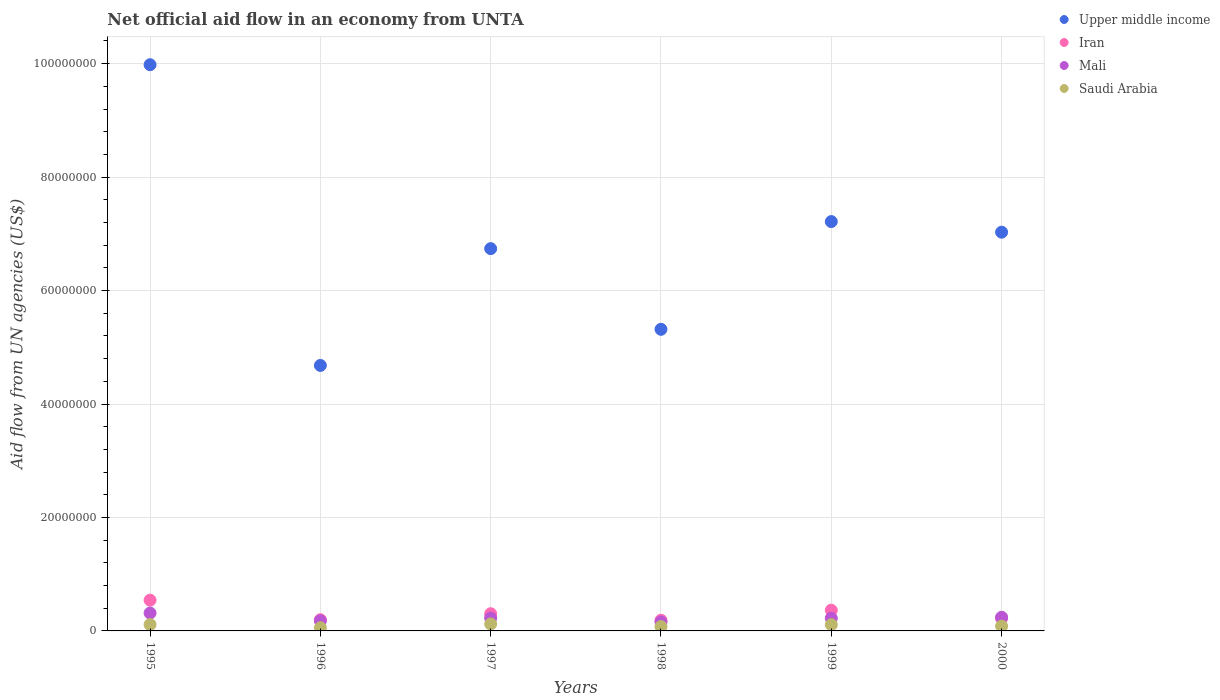Is the number of dotlines equal to the number of legend labels?
Your answer should be very brief. Yes. What is the net official aid flow in Iran in 1996?
Give a very brief answer. 1.97e+06. Across all years, what is the maximum net official aid flow in Upper middle income?
Give a very brief answer. 9.98e+07. Across all years, what is the minimum net official aid flow in Iran?
Provide a short and direct response. 1.88e+06. In which year was the net official aid flow in Mali maximum?
Offer a terse response. 1995. In which year was the net official aid flow in Mali minimum?
Provide a succinct answer. 1998. What is the total net official aid flow in Saudi Arabia in the graph?
Offer a very short reply. 5.60e+06. What is the difference between the net official aid flow in Iran in 1997 and that in 2000?
Your answer should be compact. 8.10e+05. What is the difference between the net official aid flow in Saudi Arabia in 1998 and the net official aid flow in Upper middle income in 1997?
Ensure brevity in your answer.  -6.66e+07. What is the average net official aid flow in Iran per year?
Your response must be concise. 3.03e+06. In the year 1998, what is the difference between the net official aid flow in Upper middle income and net official aid flow in Saudi Arabia?
Your response must be concise. 5.24e+07. What is the ratio of the net official aid flow in Saudi Arabia in 1995 to that in 1998?
Offer a very short reply. 1.47. Is the net official aid flow in Iran in 1995 less than that in 1998?
Ensure brevity in your answer.  No. What is the difference between the highest and the second highest net official aid flow in Mali?
Offer a very short reply. 7.40e+05. What is the difference between the highest and the lowest net official aid flow in Iran?
Offer a terse response. 3.54e+06. In how many years, is the net official aid flow in Upper middle income greater than the average net official aid flow in Upper middle income taken over all years?
Make the answer very short. 3. Does the net official aid flow in Mali monotonically increase over the years?
Offer a very short reply. No. How many dotlines are there?
Keep it short and to the point. 4. Does the graph contain grids?
Offer a very short reply. Yes. What is the title of the graph?
Offer a terse response. Net official aid flow in an economy from UNTA. Does "Ireland" appear as one of the legend labels in the graph?
Your answer should be very brief. No. What is the label or title of the X-axis?
Provide a short and direct response. Years. What is the label or title of the Y-axis?
Your response must be concise. Aid flow from UN agencies (US$). What is the Aid flow from UN agencies (US$) in Upper middle income in 1995?
Keep it short and to the point. 9.98e+07. What is the Aid flow from UN agencies (US$) in Iran in 1995?
Your answer should be compact. 5.42e+06. What is the Aid flow from UN agencies (US$) in Mali in 1995?
Provide a short and direct response. 3.15e+06. What is the Aid flow from UN agencies (US$) in Saudi Arabia in 1995?
Your answer should be very brief. 1.12e+06. What is the Aid flow from UN agencies (US$) in Upper middle income in 1996?
Ensure brevity in your answer.  4.68e+07. What is the Aid flow from UN agencies (US$) of Iran in 1996?
Provide a short and direct response. 1.97e+06. What is the Aid flow from UN agencies (US$) in Mali in 1996?
Your answer should be very brief. 1.79e+06. What is the Aid flow from UN agencies (US$) of Saudi Arabia in 1996?
Ensure brevity in your answer.  5.60e+05. What is the Aid flow from UN agencies (US$) in Upper middle income in 1997?
Your answer should be compact. 6.74e+07. What is the Aid flow from UN agencies (US$) in Iran in 1997?
Your response must be concise. 3.03e+06. What is the Aid flow from UN agencies (US$) in Mali in 1997?
Provide a short and direct response. 2.27e+06. What is the Aid flow from UN agencies (US$) of Saudi Arabia in 1997?
Your answer should be compact. 1.22e+06. What is the Aid flow from UN agencies (US$) in Upper middle income in 1998?
Provide a short and direct response. 5.32e+07. What is the Aid flow from UN agencies (US$) of Iran in 1998?
Provide a succinct answer. 1.88e+06. What is the Aid flow from UN agencies (US$) of Mali in 1998?
Ensure brevity in your answer.  1.59e+06. What is the Aid flow from UN agencies (US$) in Saudi Arabia in 1998?
Ensure brevity in your answer.  7.60e+05. What is the Aid flow from UN agencies (US$) of Upper middle income in 1999?
Provide a succinct answer. 7.22e+07. What is the Aid flow from UN agencies (US$) in Iran in 1999?
Your answer should be very brief. 3.65e+06. What is the Aid flow from UN agencies (US$) in Mali in 1999?
Ensure brevity in your answer.  2.24e+06. What is the Aid flow from UN agencies (US$) in Saudi Arabia in 1999?
Provide a succinct answer. 1.10e+06. What is the Aid flow from UN agencies (US$) in Upper middle income in 2000?
Offer a terse response. 7.03e+07. What is the Aid flow from UN agencies (US$) in Iran in 2000?
Make the answer very short. 2.22e+06. What is the Aid flow from UN agencies (US$) in Mali in 2000?
Keep it short and to the point. 2.41e+06. What is the Aid flow from UN agencies (US$) in Saudi Arabia in 2000?
Offer a very short reply. 8.40e+05. Across all years, what is the maximum Aid flow from UN agencies (US$) of Upper middle income?
Offer a terse response. 9.98e+07. Across all years, what is the maximum Aid flow from UN agencies (US$) of Iran?
Your answer should be very brief. 5.42e+06. Across all years, what is the maximum Aid flow from UN agencies (US$) of Mali?
Make the answer very short. 3.15e+06. Across all years, what is the maximum Aid flow from UN agencies (US$) in Saudi Arabia?
Give a very brief answer. 1.22e+06. Across all years, what is the minimum Aid flow from UN agencies (US$) of Upper middle income?
Keep it short and to the point. 4.68e+07. Across all years, what is the minimum Aid flow from UN agencies (US$) of Iran?
Your response must be concise. 1.88e+06. Across all years, what is the minimum Aid flow from UN agencies (US$) in Mali?
Provide a short and direct response. 1.59e+06. Across all years, what is the minimum Aid flow from UN agencies (US$) in Saudi Arabia?
Offer a terse response. 5.60e+05. What is the total Aid flow from UN agencies (US$) of Upper middle income in the graph?
Give a very brief answer. 4.10e+08. What is the total Aid flow from UN agencies (US$) of Iran in the graph?
Offer a very short reply. 1.82e+07. What is the total Aid flow from UN agencies (US$) of Mali in the graph?
Provide a short and direct response. 1.34e+07. What is the total Aid flow from UN agencies (US$) of Saudi Arabia in the graph?
Your response must be concise. 5.60e+06. What is the difference between the Aid flow from UN agencies (US$) in Upper middle income in 1995 and that in 1996?
Offer a terse response. 5.30e+07. What is the difference between the Aid flow from UN agencies (US$) of Iran in 1995 and that in 1996?
Offer a terse response. 3.45e+06. What is the difference between the Aid flow from UN agencies (US$) of Mali in 1995 and that in 1996?
Offer a terse response. 1.36e+06. What is the difference between the Aid flow from UN agencies (US$) in Saudi Arabia in 1995 and that in 1996?
Ensure brevity in your answer.  5.60e+05. What is the difference between the Aid flow from UN agencies (US$) in Upper middle income in 1995 and that in 1997?
Offer a very short reply. 3.24e+07. What is the difference between the Aid flow from UN agencies (US$) in Iran in 1995 and that in 1997?
Offer a very short reply. 2.39e+06. What is the difference between the Aid flow from UN agencies (US$) in Mali in 1995 and that in 1997?
Your answer should be compact. 8.80e+05. What is the difference between the Aid flow from UN agencies (US$) of Saudi Arabia in 1995 and that in 1997?
Provide a succinct answer. -1.00e+05. What is the difference between the Aid flow from UN agencies (US$) of Upper middle income in 1995 and that in 1998?
Your response must be concise. 4.66e+07. What is the difference between the Aid flow from UN agencies (US$) of Iran in 1995 and that in 1998?
Provide a short and direct response. 3.54e+06. What is the difference between the Aid flow from UN agencies (US$) in Mali in 1995 and that in 1998?
Offer a terse response. 1.56e+06. What is the difference between the Aid flow from UN agencies (US$) in Saudi Arabia in 1995 and that in 1998?
Ensure brevity in your answer.  3.60e+05. What is the difference between the Aid flow from UN agencies (US$) in Upper middle income in 1995 and that in 1999?
Provide a short and direct response. 2.76e+07. What is the difference between the Aid flow from UN agencies (US$) in Iran in 1995 and that in 1999?
Offer a terse response. 1.77e+06. What is the difference between the Aid flow from UN agencies (US$) in Mali in 1995 and that in 1999?
Offer a terse response. 9.10e+05. What is the difference between the Aid flow from UN agencies (US$) of Saudi Arabia in 1995 and that in 1999?
Your response must be concise. 2.00e+04. What is the difference between the Aid flow from UN agencies (US$) in Upper middle income in 1995 and that in 2000?
Provide a succinct answer. 2.95e+07. What is the difference between the Aid flow from UN agencies (US$) of Iran in 1995 and that in 2000?
Make the answer very short. 3.20e+06. What is the difference between the Aid flow from UN agencies (US$) in Mali in 1995 and that in 2000?
Your answer should be compact. 7.40e+05. What is the difference between the Aid flow from UN agencies (US$) in Upper middle income in 1996 and that in 1997?
Make the answer very short. -2.06e+07. What is the difference between the Aid flow from UN agencies (US$) in Iran in 1996 and that in 1997?
Make the answer very short. -1.06e+06. What is the difference between the Aid flow from UN agencies (US$) in Mali in 1996 and that in 1997?
Provide a short and direct response. -4.80e+05. What is the difference between the Aid flow from UN agencies (US$) in Saudi Arabia in 1996 and that in 1997?
Offer a terse response. -6.60e+05. What is the difference between the Aid flow from UN agencies (US$) of Upper middle income in 1996 and that in 1998?
Your answer should be very brief. -6.37e+06. What is the difference between the Aid flow from UN agencies (US$) of Iran in 1996 and that in 1998?
Give a very brief answer. 9.00e+04. What is the difference between the Aid flow from UN agencies (US$) of Mali in 1996 and that in 1998?
Provide a succinct answer. 2.00e+05. What is the difference between the Aid flow from UN agencies (US$) of Saudi Arabia in 1996 and that in 1998?
Your response must be concise. -2.00e+05. What is the difference between the Aid flow from UN agencies (US$) of Upper middle income in 1996 and that in 1999?
Give a very brief answer. -2.54e+07. What is the difference between the Aid flow from UN agencies (US$) of Iran in 1996 and that in 1999?
Your response must be concise. -1.68e+06. What is the difference between the Aid flow from UN agencies (US$) of Mali in 1996 and that in 1999?
Your response must be concise. -4.50e+05. What is the difference between the Aid flow from UN agencies (US$) of Saudi Arabia in 1996 and that in 1999?
Ensure brevity in your answer.  -5.40e+05. What is the difference between the Aid flow from UN agencies (US$) of Upper middle income in 1996 and that in 2000?
Your answer should be compact. -2.35e+07. What is the difference between the Aid flow from UN agencies (US$) in Mali in 1996 and that in 2000?
Make the answer very short. -6.20e+05. What is the difference between the Aid flow from UN agencies (US$) of Saudi Arabia in 1996 and that in 2000?
Make the answer very short. -2.80e+05. What is the difference between the Aid flow from UN agencies (US$) of Upper middle income in 1997 and that in 1998?
Offer a very short reply. 1.42e+07. What is the difference between the Aid flow from UN agencies (US$) in Iran in 1997 and that in 1998?
Keep it short and to the point. 1.15e+06. What is the difference between the Aid flow from UN agencies (US$) of Mali in 1997 and that in 1998?
Make the answer very short. 6.80e+05. What is the difference between the Aid flow from UN agencies (US$) of Upper middle income in 1997 and that in 1999?
Your answer should be compact. -4.77e+06. What is the difference between the Aid flow from UN agencies (US$) in Iran in 1997 and that in 1999?
Provide a succinct answer. -6.20e+05. What is the difference between the Aid flow from UN agencies (US$) of Mali in 1997 and that in 1999?
Give a very brief answer. 3.00e+04. What is the difference between the Aid flow from UN agencies (US$) in Upper middle income in 1997 and that in 2000?
Ensure brevity in your answer.  -2.90e+06. What is the difference between the Aid flow from UN agencies (US$) of Iran in 1997 and that in 2000?
Your answer should be compact. 8.10e+05. What is the difference between the Aid flow from UN agencies (US$) of Upper middle income in 1998 and that in 1999?
Keep it short and to the point. -1.90e+07. What is the difference between the Aid flow from UN agencies (US$) of Iran in 1998 and that in 1999?
Ensure brevity in your answer.  -1.77e+06. What is the difference between the Aid flow from UN agencies (US$) of Mali in 1998 and that in 1999?
Keep it short and to the point. -6.50e+05. What is the difference between the Aid flow from UN agencies (US$) of Upper middle income in 1998 and that in 2000?
Offer a terse response. -1.71e+07. What is the difference between the Aid flow from UN agencies (US$) in Mali in 1998 and that in 2000?
Make the answer very short. -8.20e+05. What is the difference between the Aid flow from UN agencies (US$) of Saudi Arabia in 1998 and that in 2000?
Provide a short and direct response. -8.00e+04. What is the difference between the Aid flow from UN agencies (US$) of Upper middle income in 1999 and that in 2000?
Provide a short and direct response. 1.87e+06. What is the difference between the Aid flow from UN agencies (US$) of Iran in 1999 and that in 2000?
Your response must be concise. 1.43e+06. What is the difference between the Aid flow from UN agencies (US$) in Upper middle income in 1995 and the Aid flow from UN agencies (US$) in Iran in 1996?
Provide a succinct answer. 9.78e+07. What is the difference between the Aid flow from UN agencies (US$) of Upper middle income in 1995 and the Aid flow from UN agencies (US$) of Mali in 1996?
Keep it short and to the point. 9.80e+07. What is the difference between the Aid flow from UN agencies (US$) of Upper middle income in 1995 and the Aid flow from UN agencies (US$) of Saudi Arabia in 1996?
Keep it short and to the point. 9.92e+07. What is the difference between the Aid flow from UN agencies (US$) of Iran in 1995 and the Aid flow from UN agencies (US$) of Mali in 1996?
Make the answer very short. 3.63e+06. What is the difference between the Aid flow from UN agencies (US$) of Iran in 1995 and the Aid flow from UN agencies (US$) of Saudi Arabia in 1996?
Keep it short and to the point. 4.86e+06. What is the difference between the Aid flow from UN agencies (US$) of Mali in 1995 and the Aid flow from UN agencies (US$) of Saudi Arabia in 1996?
Give a very brief answer. 2.59e+06. What is the difference between the Aid flow from UN agencies (US$) in Upper middle income in 1995 and the Aid flow from UN agencies (US$) in Iran in 1997?
Your answer should be very brief. 9.68e+07. What is the difference between the Aid flow from UN agencies (US$) in Upper middle income in 1995 and the Aid flow from UN agencies (US$) in Mali in 1997?
Keep it short and to the point. 9.75e+07. What is the difference between the Aid flow from UN agencies (US$) of Upper middle income in 1995 and the Aid flow from UN agencies (US$) of Saudi Arabia in 1997?
Make the answer very short. 9.86e+07. What is the difference between the Aid flow from UN agencies (US$) of Iran in 1995 and the Aid flow from UN agencies (US$) of Mali in 1997?
Make the answer very short. 3.15e+06. What is the difference between the Aid flow from UN agencies (US$) of Iran in 1995 and the Aid flow from UN agencies (US$) of Saudi Arabia in 1997?
Your answer should be very brief. 4.20e+06. What is the difference between the Aid flow from UN agencies (US$) in Mali in 1995 and the Aid flow from UN agencies (US$) in Saudi Arabia in 1997?
Make the answer very short. 1.93e+06. What is the difference between the Aid flow from UN agencies (US$) in Upper middle income in 1995 and the Aid flow from UN agencies (US$) in Iran in 1998?
Provide a short and direct response. 9.79e+07. What is the difference between the Aid flow from UN agencies (US$) of Upper middle income in 1995 and the Aid flow from UN agencies (US$) of Mali in 1998?
Keep it short and to the point. 9.82e+07. What is the difference between the Aid flow from UN agencies (US$) of Upper middle income in 1995 and the Aid flow from UN agencies (US$) of Saudi Arabia in 1998?
Make the answer very short. 9.90e+07. What is the difference between the Aid flow from UN agencies (US$) in Iran in 1995 and the Aid flow from UN agencies (US$) in Mali in 1998?
Make the answer very short. 3.83e+06. What is the difference between the Aid flow from UN agencies (US$) of Iran in 1995 and the Aid flow from UN agencies (US$) of Saudi Arabia in 1998?
Your answer should be compact. 4.66e+06. What is the difference between the Aid flow from UN agencies (US$) of Mali in 1995 and the Aid flow from UN agencies (US$) of Saudi Arabia in 1998?
Ensure brevity in your answer.  2.39e+06. What is the difference between the Aid flow from UN agencies (US$) of Upper middle income in 1995 and the Aid flow from UN agencies (US$) of Iran in 1999?
Give a very brief answer. 9.62e+07. What is the difference between the Aid flow from UN agencies (US$) in Upper middle income in 1995 and the Aid flow from UN agencies (US$) in Mali in 1999?
Your response must be concise. 9.76e+07. What is the difference between the Aid flow from UN agencies (US$) in Upper middle income in 1995 and the Aid flow from UN agencies (US$) in Saudi Arabia in 1999?
Give a very brief answer. 9.87e+07. What is the difference between the Aid flow from UN agencies (US$) in Iran in 1995 and the Aid flow from UN agencies (US$) in Mali in 1999?
Make the answer very short. 3.18e+06. What is the difference between the Aid flow from UN agencies (US$) of Iran in 1995 and the Aid flow from UN agencies (US$) of Saudi Arabia in 1999?
Provide a short and direct response. 4.32e+06. What is the difference between the Aid flow from UN agencies (US$) in Mali in 1995 and the Aid flow from UN agencies (US$) in Saudi Arabia in 1999?
Provide a short and direct response. 2.05e+06. What is the difference between the Aid flow from UN agencies (US$) in Upper middle income in 1995 and the Aid flow from UN agencies (US$) in Iran in 2000?
Give a very brief answer. 9.76e+07. What is the difference between the Aid flow from UN agencies (US$) in Upper middle income in 1995 and the Aid flow from UN agencies (US$) in Mali in 2000?
Keep it short and to the point. 9.74e+07. What is the difference between the Aid flow from UN agencies (US$) in Upper middle income in 1995 and the Aid flow from UN agencies (US$) in Saudi Arabia in 2000?
Provide a short and direct response. 9.90e+07. What is the difference between the Aid flow from UN agencies (US$) of Iran in 1995 and the Aid flow from UN agencies (US$) of Mali in 2000?
Keep it short and to the point. 3.01e+06. What is the difference between the Aid flow from UN agencies (US$) of Iran in 1995 and the Aid flow from UN agencies (US$) of Saudi Arabia in 2000?
Your response must be concise. 4.58e+06. What is the difference between the Aid flow from UN agencies (US$) in Mali in 1995 and the Aid flow from UN agencies (US$) in Saudi Arabia in 2000?
Make the answer very short. 2.31e+06. What is the difference between the Aid flow from UN agencies (US$) in Upper middle income in 1996 and the Aid flow from UN agencies (US$) in Iran in 1997?
Ensure brevity in your answer.  4.38e+07. What is the difference between the Aid flow from UN agencies (US$) in Upper middle income in 1996 and the Aid flow from UN agencies (US$) in Mali in 1997?
Your response must be concise. 4.45e+07. What is the difference between the Aid flow from UN agencies (US$) in Upper middle income in 1996 and the Aid flow from UN agencies (US$) in Saudi Arabia in 1997?
Offer a terse response. 4.56e+07. What is the difference between the Aid flow from UN agencies (US$) in Iran in 1996 and the Aid flow from UN agencies (US$) in Mali in 1997?
Give a very brief answer. -3.00e+05. What is the difference between the Aid flow from UN agencies (US$) in Iran in 1996 and the Aid flow from UN agencies (US$) in Saudi Arabia in 1997?
Provide a short and direct response. 7.50e+05. What is the difference between the Aid flow from UN agencies (US$) of Mali in 1996 and the Aid flow from UN agencies (US$) of Saudi Arabia in 1997?
Offer a very short reply. 5.70e+05. What is the difference between the Aid flow from UN agencies (US$) in Upper middle income in 1996 and the Aid flow from UN agencies (US$) in Iran in 1998?
Your answer should be very brief. 4.49e+07. What is the difference between the Aid flow from UN agencies (US$) in Upper middle income in 1996 and the Aid flow from UN agencies (US$) in Mali in 1998?
Make the answer very short. 4.52e+07. What is the difference between the Aid flow from UN agencies (US$) of Upper middle income in 1996 and the Aid flow from UN agencies (US$) of Saudi Arabia in 1998?
Ensure brevity in your answer.  4.60e+07. What is the difference between the Aid flow from UN agencies (US$) of Iran in 1996 and the Aid flow from UN agencies (US$) of Saudi Arabia in 1998?
Your response must be concise. 1.21e+06. What is the difference between the Aid flow from UN agencies (US$) in Mali in 1996 and the Aid flow from UN agencies (US$) in Saudi Arabia in 1998?
Provide a succinct answer. 1.03e+06. What is the difference between the Aid flow from UN agencies (US$) in Upper middle income in 1996 and the Aid flow from UN agencies (US$) in Iran in 1999?
Make the answer very short. 4.32e+07. What is the difference between the Aid flow from UN agencies (US$) of Upper middle income in 1996 and the Aid flow from UN agencies (US$) of Mali in 1999?
Offer a very short reply. 4.46e+07. What is the difference between the Aid flow from UN agencies (US$) in Upper middle income in 1996 and the Aid flow from UN agencies (US$) in Saudi Arabia in 1999?
Your response must be concise. 4.57e+07. What is the difference between the Aid flow from UN agencies (US$) in Iran in 1996 and the Aid flow from UN agencies (US$) in Saudi Arabia in 1999?
Provide a short and direct response. 8.70e+05. What is the difference between the Aid flow from UN agencies (US$) of Mali in 1996 and the Aid flow from UN agencies (US$) of Saudi Arabia in 1999?
Offer a very short reply. 6.90e+05. What is the difference between the Aid flow from UN agencies (US$) in Upper middle income in 1996 and the Aid flow from UN agencies (US$) in Iran in 2000?
Your response must be concise. 4.46e+07. What is the difference between the Aid flow from UN agencies (US$) of Upper middle income in 1996 and the Aid flow from UN agencies (US$) of Mali in 2000?
Make the answer very short. 4.44e+07. What is the difference between the Aid flow from UN agencies (US$) of Upper middle income in 1996 and the Aid flow from UN agencies (US$) of Saudi Arabia in 2000?
Ensure brevity in your answer.  4.60e+07. What is the difference between the Aid flow from UN agencies (US$) in Iran in 1996 and the Aid flow from UN agencies (US$) in Mali in 2000?
Make the answer very short. -4.40e+05. What is the difference between the Aid flow from UN agencies (US$) in Iran in 1996 and the Aid flow from UN agencies (US$) in Saudi Arabia in 2000?
Provide a short and direct response. 1.13e+06. What is the difference between the Aid flow from UN agencies (US$) in Mali in 1996 and the Aid flow from UN agencies (US$) in Saudi Arabia in 2000?
Provide a succinct answer. 9.50e+05. What is the difference between the Aid flow from UN agencies (US$) in Upper middle income in 1997 and the Aid flow from UN agencies (US$) in Iran in 1998?
Make the answer very short. 6.55e+07. What is the difference between the Aid flow from UN agencies (US$) of Upper middle income in 1997 and the Aid flow from UN agencies (US$) of Mali in 1998?
Make the answer very short. 6.58e+07. What is the difference between the Aid flow from UN agencies (US$) of Upper middle income in 1997 and the Aid flow from UN agencies (US$) of Saudi Arabia in 1998?
Your answer should be compact. 6.66e+07. What is the difference between the Aid flow from UN agencies (US$) of Iran in 1997 and the Aid flow from UN agencies (US$) of Mali in 1998?
Offer a very short reply. 1.44e+06. What is the difference between the Aid flow from UN agencies (US$) in Iran in 1997 and the Aid flow from UN agencies (US$) in Saudi Arabia in 1998?
Offer a very short reply. 2.27e+06. What is the difference between the Aid flow from UN agencies (US$) of Mali in 1997 and the Aid flow from UN agencies (US$) of Saudi Arabia in 1998?
Offer a terse response. 1.51e+06. What is the difference between the Aid flow from UN agencies (US$) in Upper middle income in 1997 and the Aid flow from UN agencies (US$) in Iran in 1999?
Make the answer very short. 6.37e+07. What is the difference between the Aid flow from UN agencies (US$) in Upper middle income in 1997 and the Aid flow from UN agencies (US$) in Mali in 1999?
Keep it short and to the point. 6.52e+07. What is the difference between the Aid flow from UN agencies (US$) in Upper middle income in 1997 and the Aid flow from UN agencies (US$) in Saudi Arabia in 1999?
Make the answer very short. 6.63e+07. What is the difference between the Aid flow from UN agencies (US$) in Iran in 1997 and the Aid flow from UN agencies (US$) in Mali in 1999?
Your response must be concise. 7.90e+05. What is the difference between the Aid flow from UN agencies (US$) of Iran in 1997 and the Aid flow from UN agencies (US$) of Saudi Arabia in 1999?
Provide a short and direct response. 1.93e+06. What is the difference between the Aid flow from UN agencies (US$) of Mali in 1997 and the Aid flow from UN agencies (US$) of Saudi Arabia in 1999?
Give a very brief answer. 1.17e+06. What is the difference between the Aid flow from UN agencies (US$) in Upper middle income in 1997 and the Aid flow from UN agencies (US$) in Iran in 2000?
Offer a very short reply. 6.52e+07. What is the difference between the Aid flow from UN agencies (US$) in Upper middle income in 1997 and the Aid flow from UN agencies (US$) in Mali in 2000?
Offer a very short reply. 6.50e+07. What is the difference between the Aid flow from UN agencies (US$) in Upper middle income in 1997 and the Aid flow from UN agencies (US$) in Saudi Arabia in 2000?
Your response must be concise. 6.66e+07. What is the difference between the Aid flow from UN agencies (US$) of Iran in 1997 and the Aid flow from UN agencies (US$) of Mali in 2000?
Offer a very short reply. 6.20e+05. What is the difference between the Aid flow from UN agencies (US$) in Iran in 1997 and the Aid flow from UN agencies (US$) in Saudi Arabia in 2000?
Provide a succinct answer. 2.19e+06. What is the difference between the Aid flow from UN agencies (US$) of Mali in 1997 and the Aid flow from UN agencies (US$) of Saudi Arabia in 2000?
Your answer should be compact. 1.43e+06. What is the difference between the Aid flow from UN agencies (US$) of Upper middle income in 1998 and the Aid flow from UN agencies (US$) of Iran in 1999?
Give a very brief answer. 4.95e+07. What is the difference between the Aid flow from UN agencies (US$) in Upper middle income in 1998 and the Aid flow from UN agencies (US$) in Mali in 1999?
Offer a terse response. 5.09e+07. What is the difference between the Aid flow from UN agencies (US$) in Upper middle income in 1998 and the Aid flow from UN agencies (US$) in Saudi Arabia in 1999?
Make the answer very short. 5.21e+07. What is the difference between the Aid flow from UN agencies (US$) of Iran in 1998 and the Aid flow from UN agencies (US$) of Mali in 1999?
Your answer should be compact. -3.60e+05. What is the difference between the Aid flow from UN agencies (US$) of Iran in 1998 and the Aid flow from UN agencies (US$) of Saudi Arabia in 1999?
Your response must be concise. 7.80e+05. What is the difference between the Aid flow from UN agencies (US$) in Upper middle income in 1998 and the Aid flow from UN agencies (US$) in Iran in 2000?
Make the answer very short. 5.10e+07. What is the difference between the Aid flow from UN agencies (US$) in Upper middle income in 1998 and the Aid flow from UN agencies (US$) in Mali in 2000?
Your answer should be very brief. 5.08e+07. What is the difference between the Aid flow from UN agencies (US$) in Upper middle income in 1998 and the Aid flow from UN agencies (US$) in Saudi Arabia in 2000?
Make the answer very short. 5.23e+07. What is the difference between the Aid flow from UN agencies (US$) in Iran in 1998 and the Aid flow from UN agencies (US$) in Mali in 2000?
Provide a succinct answer. -5.30e+05. What is the difference between the Aid flow from UN agencies (US$) of Iran in 1998 and the Aid flow from UN agencies (US$) of Saudi Arabia in 2000?
Your response must be concise. 1.04e+06. What is the difference between the Aid flow from UN agencies (US$) in Mali in 1998 and the Aid flow from UN agencies (US$) in Saudi Arabia in 2000?
Offer a very short reply. 7.50e+05. What is the difference between the Aid flow from UN agencies (US$) in Upper middle income in 1999 and the Aid flow from UN agencies (US$) in Iran in 2000?
Provide a succinct answer. 6.99e+07. What is the difference between the Aid flow from UN agencies (US$) in Upper middle income in 1999 and the Aid flow from UN agencies (US$) in Mali in 2000?
Give a very brief answer. 6.98e+07. What is the difference between the Aid flow from UN agencies (US$) in Upper middle income in 1999 and the Aid flow from UN agencies (US$) in Saudi Arabia in 2000?
Your answer should be compact. 7.13e+07. What is the difference between the Aid flow from UN agencies (US$) in Iran in 1999 and the Aid flow from UN agencies (US$) in Mali in 2000?
Give a very brief answer. 1.24e+06. What is the difference between the Aid flow from UN agencies (US$) in Iran in 1999 and the Aid flow from UN agencies (US$) in Saudi Arabia in 2000?
Your response must be concise. 2.81e+06. What is the difference between the Aid flow from UN agencies (US$) of Mali in 1999 and the Aid flow from UN agencies (US$) of Saudi Arabia in 2000?
Your answer should be very brief. 1.40e+06. What is the average Aid flow from UN agencies (US$) in Upper middle income per year?
Make the answer very short. 6.83e+07. What is the average Aid flow from UN agencies (US$) in Iran per year?
Your answer should be very brief. 3.03e+06. What is the average Aid flow from UN agencies (US$) of Mali per year?
Your response must be concise. 2.24e+06. What is the average Aid flow from UN agencies (US$) of Saudi Arabia per year?
Your answer should be very brief. 9.33e+05. In the year 1995, what is the difference between the Aid flow from UN agencies (US$) of Upper middle income and Aid flow from UN agencies (US$) of Iran?
Make the answer very short. 9.44e+07. In the year 1995, what is the difference between the Aid flow from UN agencies (US$) of Upper middle income and Aid flow from UN agencies (US$) of Mali?
Make the answer very short. 9.67e+07. In the year 1995, what is the difference between the Aid flow from UN agencies (US$) in Upper middle income and Aid flow from UN agencies (US$) in Saudi Arabia?
Make the answer very short. 9.87e+07. In the year 1995, what is the difference between the Aid flow from UN agencies (US$) of Iran and Aid flow from UN agencies (US$) of Mali?
Give a very brief answer. 2.27e+06. In the year 1995, what is the difference between the Aid flow from UN agencies (US$) in Iran and Aid flow from UN agencies (US$) in Saudi Arabia?
Your answer should be very brief. 4.30e+06. In the year 1995, what is the difference between the Aid flow from UN agencies (US$) in Mali and Aid flow from UN agencies (US$) in Saudi Arabia?
Offer a very short reply. 2.03e+06. In the year 1996, what is the difference between the Aid flow from UN agencies (US$) in Upper middle income and Aid flow from UN agencies (US$) in Iran?
Provide a short and direct response. 4.48e+07. In the year 1996, what is the difference between the Aid flow from UN agencies (US$) of Upper middle income and Aid flow from UN agencies (US$) of Mali?
Offer a very short reply. 4.50e+07. In the year 1996, what is the difference between the Aid flow from UN agencies (US$) in Upper middle income and Aid flow from UN agencies (US$) in Saudi Arabia?
Your answer should be compact. 4.62e+07. In the year 1996, what is the difference between the Aid flow from UN agencies (US$) of Iran and Aid flow from UN agencies (US$) of Mali?
Your answer should be very brief. 1.80e+05. In the year 1996, what is the difference between the Aid flow from UN agencies (US$) in Iran and Aid flow from UN agencies (US$) in Saudi Arabia?
Offer a very short reply. 1.41e+06. In the year 1996, what is the difference between the Aid flow from UN agencies (US$) in Mali and Aid flow from UN agencies (US$) in Saudi Arabia?
Offer a very short reply. 1.23e+06. In the year 1997, what is the difference between the Aid flow from UN agencies (US$) in Upper middle income and Aid flow from UN agencies (US$) in Iran?
Your response must be concise. 6.44e+07. In the year 1997, what is the difference between the Aid flow from UN agencies (US$) in Upper middle income and Aid flow from UN agencies (US$) in Mali?
Your answer should be compact. 6.51e+07. In the year 1997, what is the difference between the Aid flow from UN agencies (US$) of Upper middle income and Aid flow from UN agencies (US$) of Saudi Arabia?
Your response must be concise. 6.62e+07. In the year 1997, what is the difference between the Aid flow from UN agencies (US$) of Iran and Aid flow from UN agencies (US$) of Mali?
Keep it short and to the point. 7.60e+05. In the year 1997, what is the difference between the Aid flow from UN agencies (US$) of Iran and Aid flow from UN agencies (US$) of Saudi Arabia?
Offer a very short reply. 1.81e+06. In the year 1997, what is the difference between the Aid flow from UN agencies (US$) of Mali and Aid flow from UN agencies (US$) of Saudi Arabia?
Ensure brevity in your answer.  1.05e+06. In the year 1998, what is the difference between the Aid flow from UN agencies (US$) in Upper middle income and Aid flow from UN agencies (US$) in Iran?
Your answer should be compact. 5.13e+07. In the year 1998, what is the difference between the Aid flow from UN agencies (US$) in Upper middle income and Aid flow from UN agencies (US$) in Mali?
Your answer should be compact. 5.16e+07. In the year 1998, what is the difference between the Aid flow from UN agencies (US$) of Upper middle income and Aid flow from UN agencies (US$) of Saudi Arabia?
Your response must be concise. 5.24e+07. In the year 1998, what is the difference between the Aid flow from UN agencies (US$) in Iran and Aid flow from UN agencies (US$) in Mali?
Your answer should be compact. 2.90e+05. In the year 1998, what is the difference between the Aid flow from UN agencies (US$) of Iran and Aid flow from UN agencies (US$) of Saudi Arabia?
Keep it short and to the point. 1.12e+06. In the year 1998, what is the difference between the Aid flow from UN agencies (US$) of Mali and Aid flow from UN agencies (US$) of Saudi Arabia?
Your answer should be compact. 8.30e+05. In the year 1999, what is the difference between the Aid flow from UN agencies (US$) of Upper middle income and Aid flow from UN agencies (US$) of Iran?
Keep it short and to the point. 6.85e+07. In the year 1999, what is the difference between the Aid flow from UN agencies (US$) of Upper middle income and Aid flow from UN agencies (US$) of Mali?
Provide a succinct answer. 6.99e+07. In the year 1999, what is the difference between the Aid flow from UN agencies (US$) of Upper middle income and Aid flow from UN agencies (US$) of Saudi Arabia?
Provide a succinct answer. 7.11e+07. In the year 1999, what is the difference between the Aid flow from UN agencies (US$) in Iran and Aid flow from UN agencies (US$) in Mali?
Keep it short and to the point. 1.41e+06. In the year 1999, what is the difference between the Aid flow from UN agencies (US$) in Iran and Aid flow from UN agencies (US$) in Saudi Arabia?
Ensure brevity in your answer.  2.55e+06. In the year 1999, what is the difference between the Aid flow from UN agencies (US$) of Mali and Aid flow from UN agencies (US$) of Saudi Arabia?
Provide a succinct answer. 1.14e+06. In the year 2000, what is the difference between the Aid flow from UN agencies (US$) of Upper middle income and Aid flow from UN agencies (US$) of Iran?
Your answer should be very brief. 6.81e+07. In the year 2000, what is the difference between the Aid flow from UN agencies (US$) in Upper middle income and Aid flow from UN agencies (US$) in Mali?
Keep it short and to the point. 6.79e+07. In the year 2000, what is the difference between the Aid flow from UN agencies (US$) in Upper middle income and Aid flow from UN agencies (US$) in Saudi Arabia?
Offer a terse response. 6.94e+07. In the year 2000, what is the difference between the Aid flow from UN agencies (US$) in Iran and Aid flow from UN agencies (US$) in Mali?
Your response must be concise. -1.90e+05. In the year 2000, what is the difference between the Aid flow from UN agencies (US$) of Iran and Aid flow from UN agencies (US$) of Saudi Arabia?
Make the answer very short. 1.38e+06. In the year 2000, what is the difference between the Aid flow from UN agencies (US$) of Mali and Aid flow from UN agencies (US$) of Saudi Arabia?
Ensure brevity in your answer.  1.57e+06. What is the ratio of the Aid flow from UN agencies (US$) in Upper middle income in 1995 to that in 1996?
Provide a short and direct response. 2.13. What is the ratio of the Aid flow from UN agencies (US$) in Iran in 1995 to that in 1996?
Your response must be concise. 2.75. What is the ratio of the Aid flow from UN agencies (US$) of Mali in 1995 to that in 1996?
Your answer should be compact. 1.76. What is the ratio of the Aid flow from UN agencies (US$) of Saudi Arabia in 1995 to that in 1996?
Provide a succinct answer. 2. What is the ratio of the Aid flow from UN agencies (US$) of Upper middle income in 1995 to that in 1997?
Your answer should be compact. 1.48. What is the ratio of the Aid flow from UN agencies (US$) of Iran in 1995 to that in 1997?
Your response must be concise. 1.79. What is the ratio of the Aid flow from UN agencies (US$) in Mali in 1995 to that in 1997?
Ensure brevity in your answer.  1.39. What is the ratio of the Aid flow from UN agencies (US$) in Saudi Arabia in 1995 to that in 1997?
Keep it short and to the point. 0.92. What is the ratio of the Aid flow from UN agencies (US$) of Upper middle income in 1995 to that in 1998?
Provide a succinct answer. 1.88. What is the ratio of the Aid flow from UN agencies (US$) of Iran in 1995 to that in 1998?
Your answer should be very brief. 2.88. What is the ratio of the Aid flow from UN agencies (US$) of Mali in 1995 to that in 1998?
Give a very brief answer. 1.98. What is the ratio of the Aid flow from UN agencies (US$) in Saudi Arabia in 1995 to that in 1998?
Give a very brief answer. 1.47. What is the ratio of the Aid flow from UN agencies (US$) in Upper middle income in 1995 to that in 1999?
Make the answer very short. 1.38. What is the ratio of the Aid flow from UN agencies (US$) of Iran in 1995 to that in 1999?
Offer a terse response. 1.48. What is the ratio of the Aid flow from UN agencies (US$) in Mali in 1995 to that in 1999?
Your response must be concise. 1.41. What is the ratio of the Aid flow from UN agencies (US$) in Saudi Arabia in 1995 to that in 1999?
Your answer should be compact. 1.02. What is the ratio of the Aid flow from UN agencies (US$) of Upper middle income in 1995 to that in 2000?
Provide a short and direct response. 1.42. What is the ratio of the Aid flow from UN agencies (US$) of Iran in 1995 to that in 2000?
Offer a terse response. 2.44. What is the ratio of the Aid flow from UN agencies (US$) of Mali in 1995 to that in 2000?
Your response must be concise. 1.31. What is the ratio of the Aid flow from UN agencies (US$) in Upper middle income in 1996 to that in 1997?
Give a very brief answer. 0.69. What is the ratio of the Aid flow from UN agencies (US$) of Iran in 1996 to that in 1997?
Your answer should be very brief. 0.65. What is the ratio of the Aid flow from UN agencies (US$) in Mali in 1996 to that in 1997?
Provide a succinct answer. 0.79. What is the ratio of the Aid flow from UN agencies (US$) of Saudi Arabia in 1996 to that in 1997?
Your answer should be compact. 0.46. What is the ratio of the Aid flow from UN agencies (US$) of Upper middle income in 1996 to that in 1998?
Provide a short and direct response. 0.88. What is the ratio of the Aid flow from UN agencies (US$) of Iran in 1996 to that in 1998?
Keep it short and to the point. 1.05. What is the ratio of the Aid flow from UN agencies (US$) of Mali in 1996 to that in 1998?
Provide a succinct answer. 1.13. What is the ratio of the Aid flow from UN agencies (US$) of Saudi Arabia in 1996 to that in 1998?
Make the answer very short. 0.74. What is the ratio of the Aid flow from UN agencies (US$) of Upper middle income in 1996 to that in 1999?
Your answer should be very brief. 0.65. What is the ratio of the Aid flow from UN agencies (US$) of Iran in 1996 to that in 1999?
Keep it short and to the point. 0.54. What is the ratio of the Aid flow from UN agencies (US$) of Mali in 1996 to that in 1999?
Offer a terse response. 0.8. What is the ratio of the Aid flow from UN agencies (US$) of Saudi Arabia in 1996 to that in 1999?
Ensure brevity in your answer.  0.51. What is the ratio of the Aid flow from UN agencies (US$) in Upper middle income in 1996 to that in 2000?
Offer a very short reply. 0.67. What is the ratio of the Aid flow from UN agencies (US$) in Iran in 1996 to that in 2000?
Your response must be concise. 0.89. What is the ratio of the Aid flow from UN agencies (US$) in Mali in 1996 to that in 2000?
Your response must be concise. 0.74. What is the ratio of the Aid flow from UN agencies (US$) of Saudi Arabia in 1996 to that in 2000?
Your response must be concise. 0.67. What is the ratio of the Aid flow from UN agencies (US$) in Upper middle income in 1997 to that in 1998?
Your response must be concise. 1.27. What is the ratio of the Aid flow from UN agencies (US$) in Iran in 1997 to that in 1998?
Make the answer very short. 1.61. What is the ratio of the Aid flow from UN agencies (US$) of Mali in 1997 to that in 1998?
Offer a very short reply. 1.43. What is the ratio of the Aid flow from UN agencies (US$) of Saudi Arabia in 1997 to that in 1998?
Provide a short and direct response. 1.61. What is the ratio of the Aid flow from UN agencies (US$) in Upper middle income in 1997 to that in 1999?
Your response must be concise. 0.93. What is the ratio of the Aid flow from UN agencies (US$) in Iran in 1997 to that in 1999?
Offer a terse response. 0.83. What is the ratio of the Aid flow from UN agencies (US$) in Mali in 1997 to that in 1999?
Make the answer very short. 1.01. What is the ratio of the Aid flow from UN agencies (US$) in Saudi Arabia in 1997 to that in 1999?
Your response must be concise. 1.11. What is the ratio of the Aid flow from UN agencies (US$) in Upper middle income in 1997 to that in 2000?
Your answer should be very brief. 0.96. What is the ratio of the Aid flow from UN agencies (US$) of Iran in 1997 to that in 2000?
Offer a very short reply. 1.36. What is the ratio of the Aid flow from UN agencies (US$) in Mali in 1997 to that in 2000?
Your answer should be very brief. 0.94. What is the ratio of the Aid flow from UN agencies (US$) of Saudi Arabia in 1997 to that in 2000?
Provide a succinct answer. 1.45. What is the ratio of the Aid flow from UN agencies (US$) in Upper middle income in 1998 to that in 1999?
Give a very brief answer. 0.74. What is the ratio of the Aid flow from UN agencies (US$) in Iran in 1998 to that in 1999?
Provide a succinct answer. 0.52. What is the ratio of the Aid flow from UN agencies (US$) in Mali in 1998 to that in 1999?
Offer a very short reply. 0.71. What is the ratio of the Aid flow from UN agencies (US$) of Saudi Arabia in 1998 to that in 1999?
Provide a succinct answer. 0.69. What is the ratio of the Aid flow from UN agencies (US$) of Upper middle income in 1998 to that in 2000?
Keep it short and to the point. 0.76. What is the ratio of the Aid flow from UN agencies (US$) in Iran in 1998 to that in 2000?
Your answer should be compact. 0.85. What is the ratio of the Aid flow from UN agencies (US$) of Mali in 1998 to that in 2000?
Provide a succinct answer. 0.66. What is the ratio of the Aid flow from UN agencies (US$) of Saudi Arabia in 1998 to that in 2000?
Give a very brief answer. 0.9. What is the ratio of the Aid flow from UN agencies (US$) of Upper middle income in 1999 to that in 2000?
Offer a very short reply. 1.03. What is the ratio of the Aid flow from UN agencies (US$) of Iran in 1999 to that in 2000?
Give a very brief answer. 1.64. What is the ratio of the Aid flow from UN agencies (US$) of Mali in 1999 to that in 2000?
Keep it short and to the point. 0.93. What is the ratio of the Aid flow from UN agencies (US$) in Saudi Arabia in 1999 to that in 2000?
Keep it short and to the point. 1.31. What is the difference between the highest and the second highest Aid flow from UN agencies (US$) in Upper middle income?
Offer a very short reply. 2.76e+07. What is the difference between the highest and the second highest Aid flow from UN agencies (US$) of Iran?
Your answer should be compact. 1.77e+06. What is the difference between the highest and the second highest Aid flow from UN agencies (US$) of Mali?
Offer a terse response. 7.40e+05. What is the difference between the highest and the lowest Aid flow from UN agencies (US$) of Upper middle income?
Give a very brief answer. 5.30e+07. What is the difference between the highest and the lowest Aid flow from UN agencies (US$) of Iran?
Your answer should be compact. 3.54e+06. What is the difference between the highest and the lowest Aid flow from UN agencies (US$) in Mali?
Keep it short and to the point. 1.56e+06. What is the difference between the highest and the lowest Aid flow from UN agencies (US$) in Saudi Arabia?
Provide a succinct answer. 6.60e+05. 